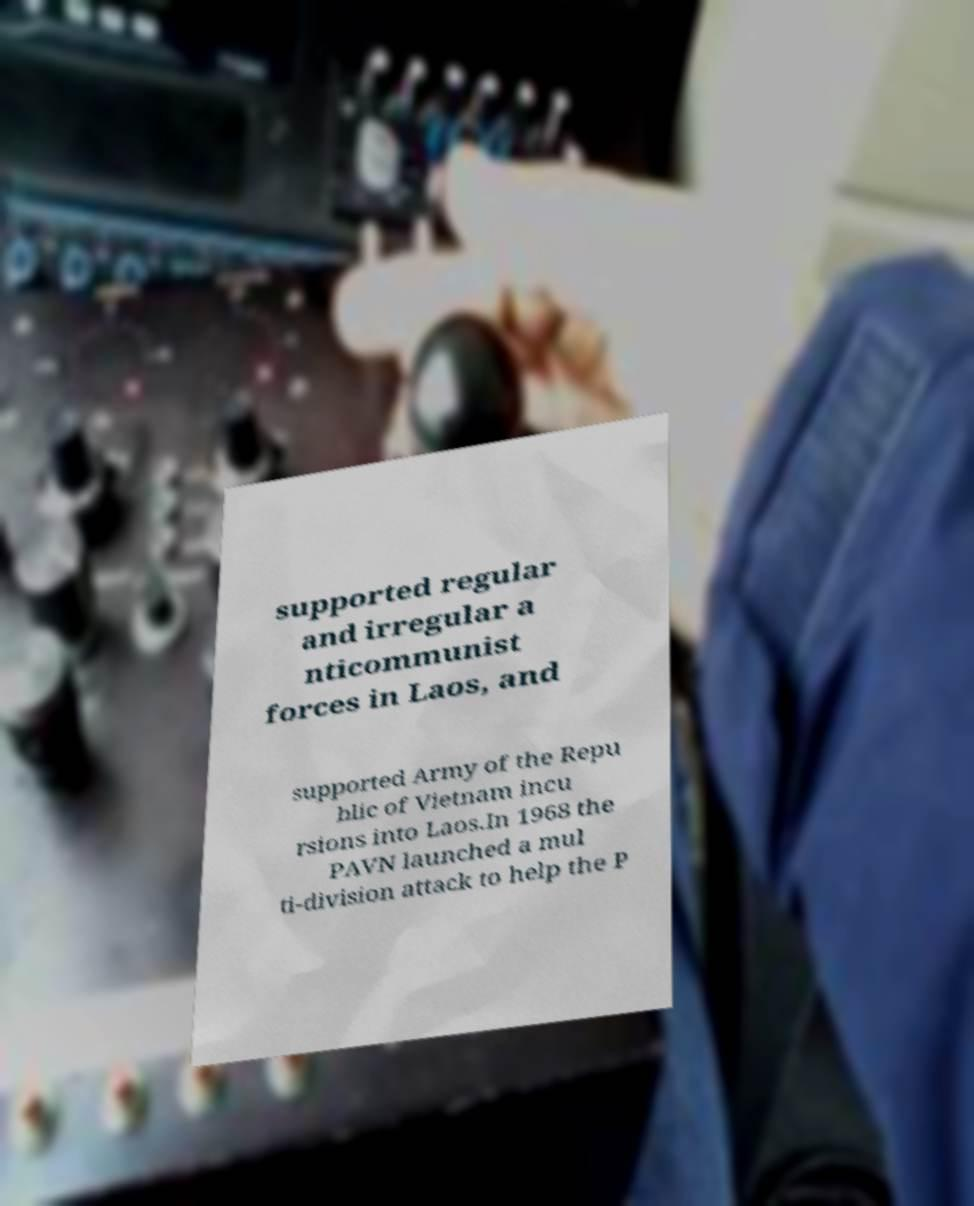For documentation purposes, I need the text within this image transcribed. Could you provide that? supported regular and irregular a nticommunist forces in Laos, and supported Army of the Repu blic of Vietnam incu rsions into Laos.In 1968 the PAVN launched a mul ti-division attack to help the P 